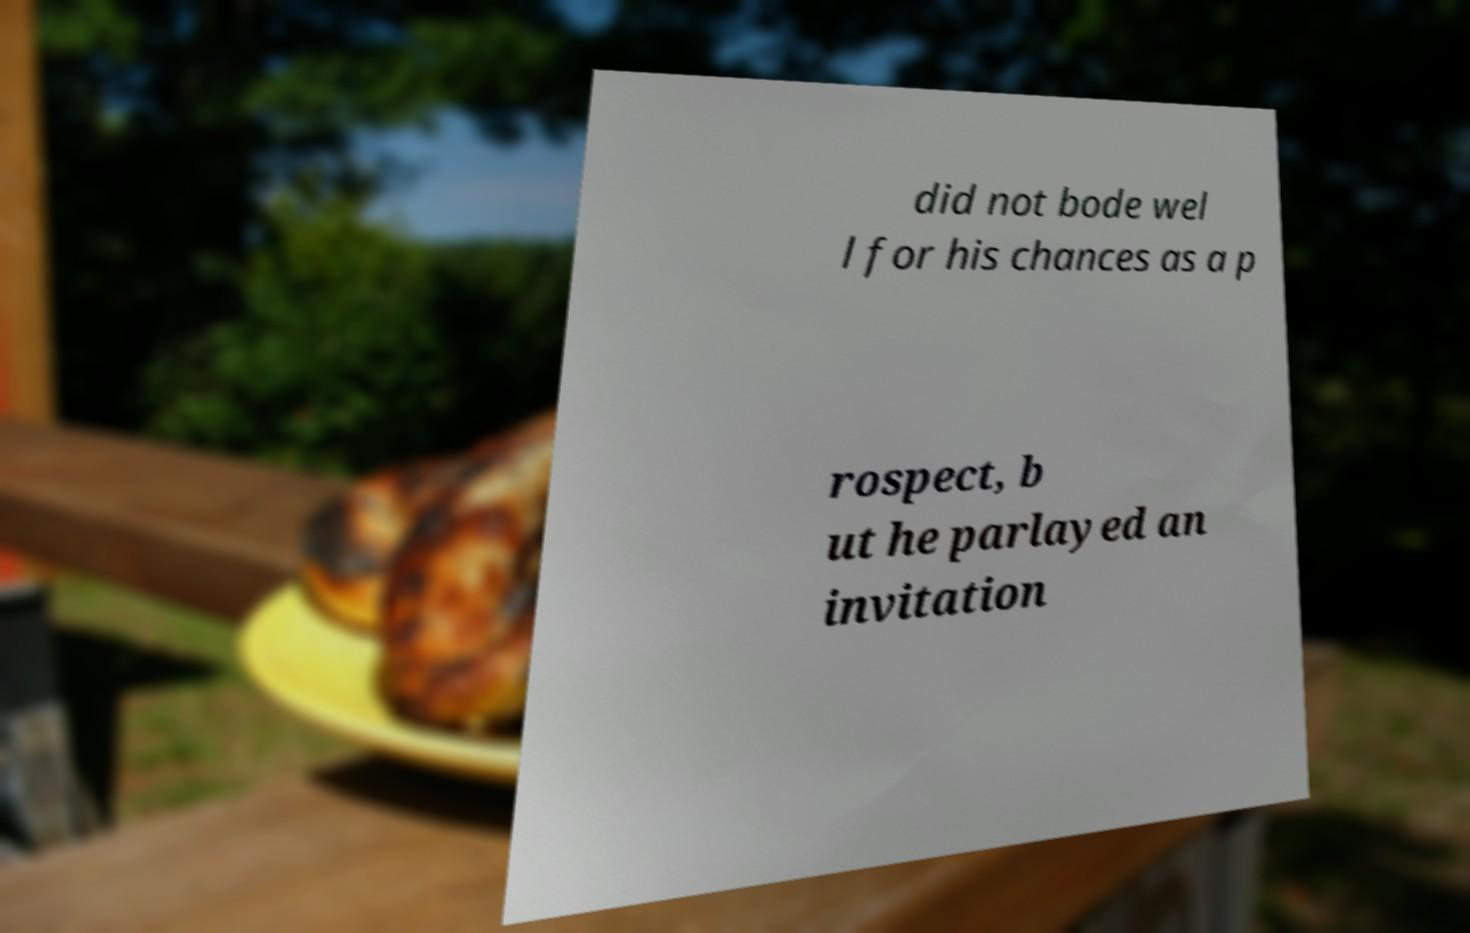Please read and relay the text visible in this image. What does it say? did not bode wel l for his chances as a p rospect, b ut he parlayed an invitation 